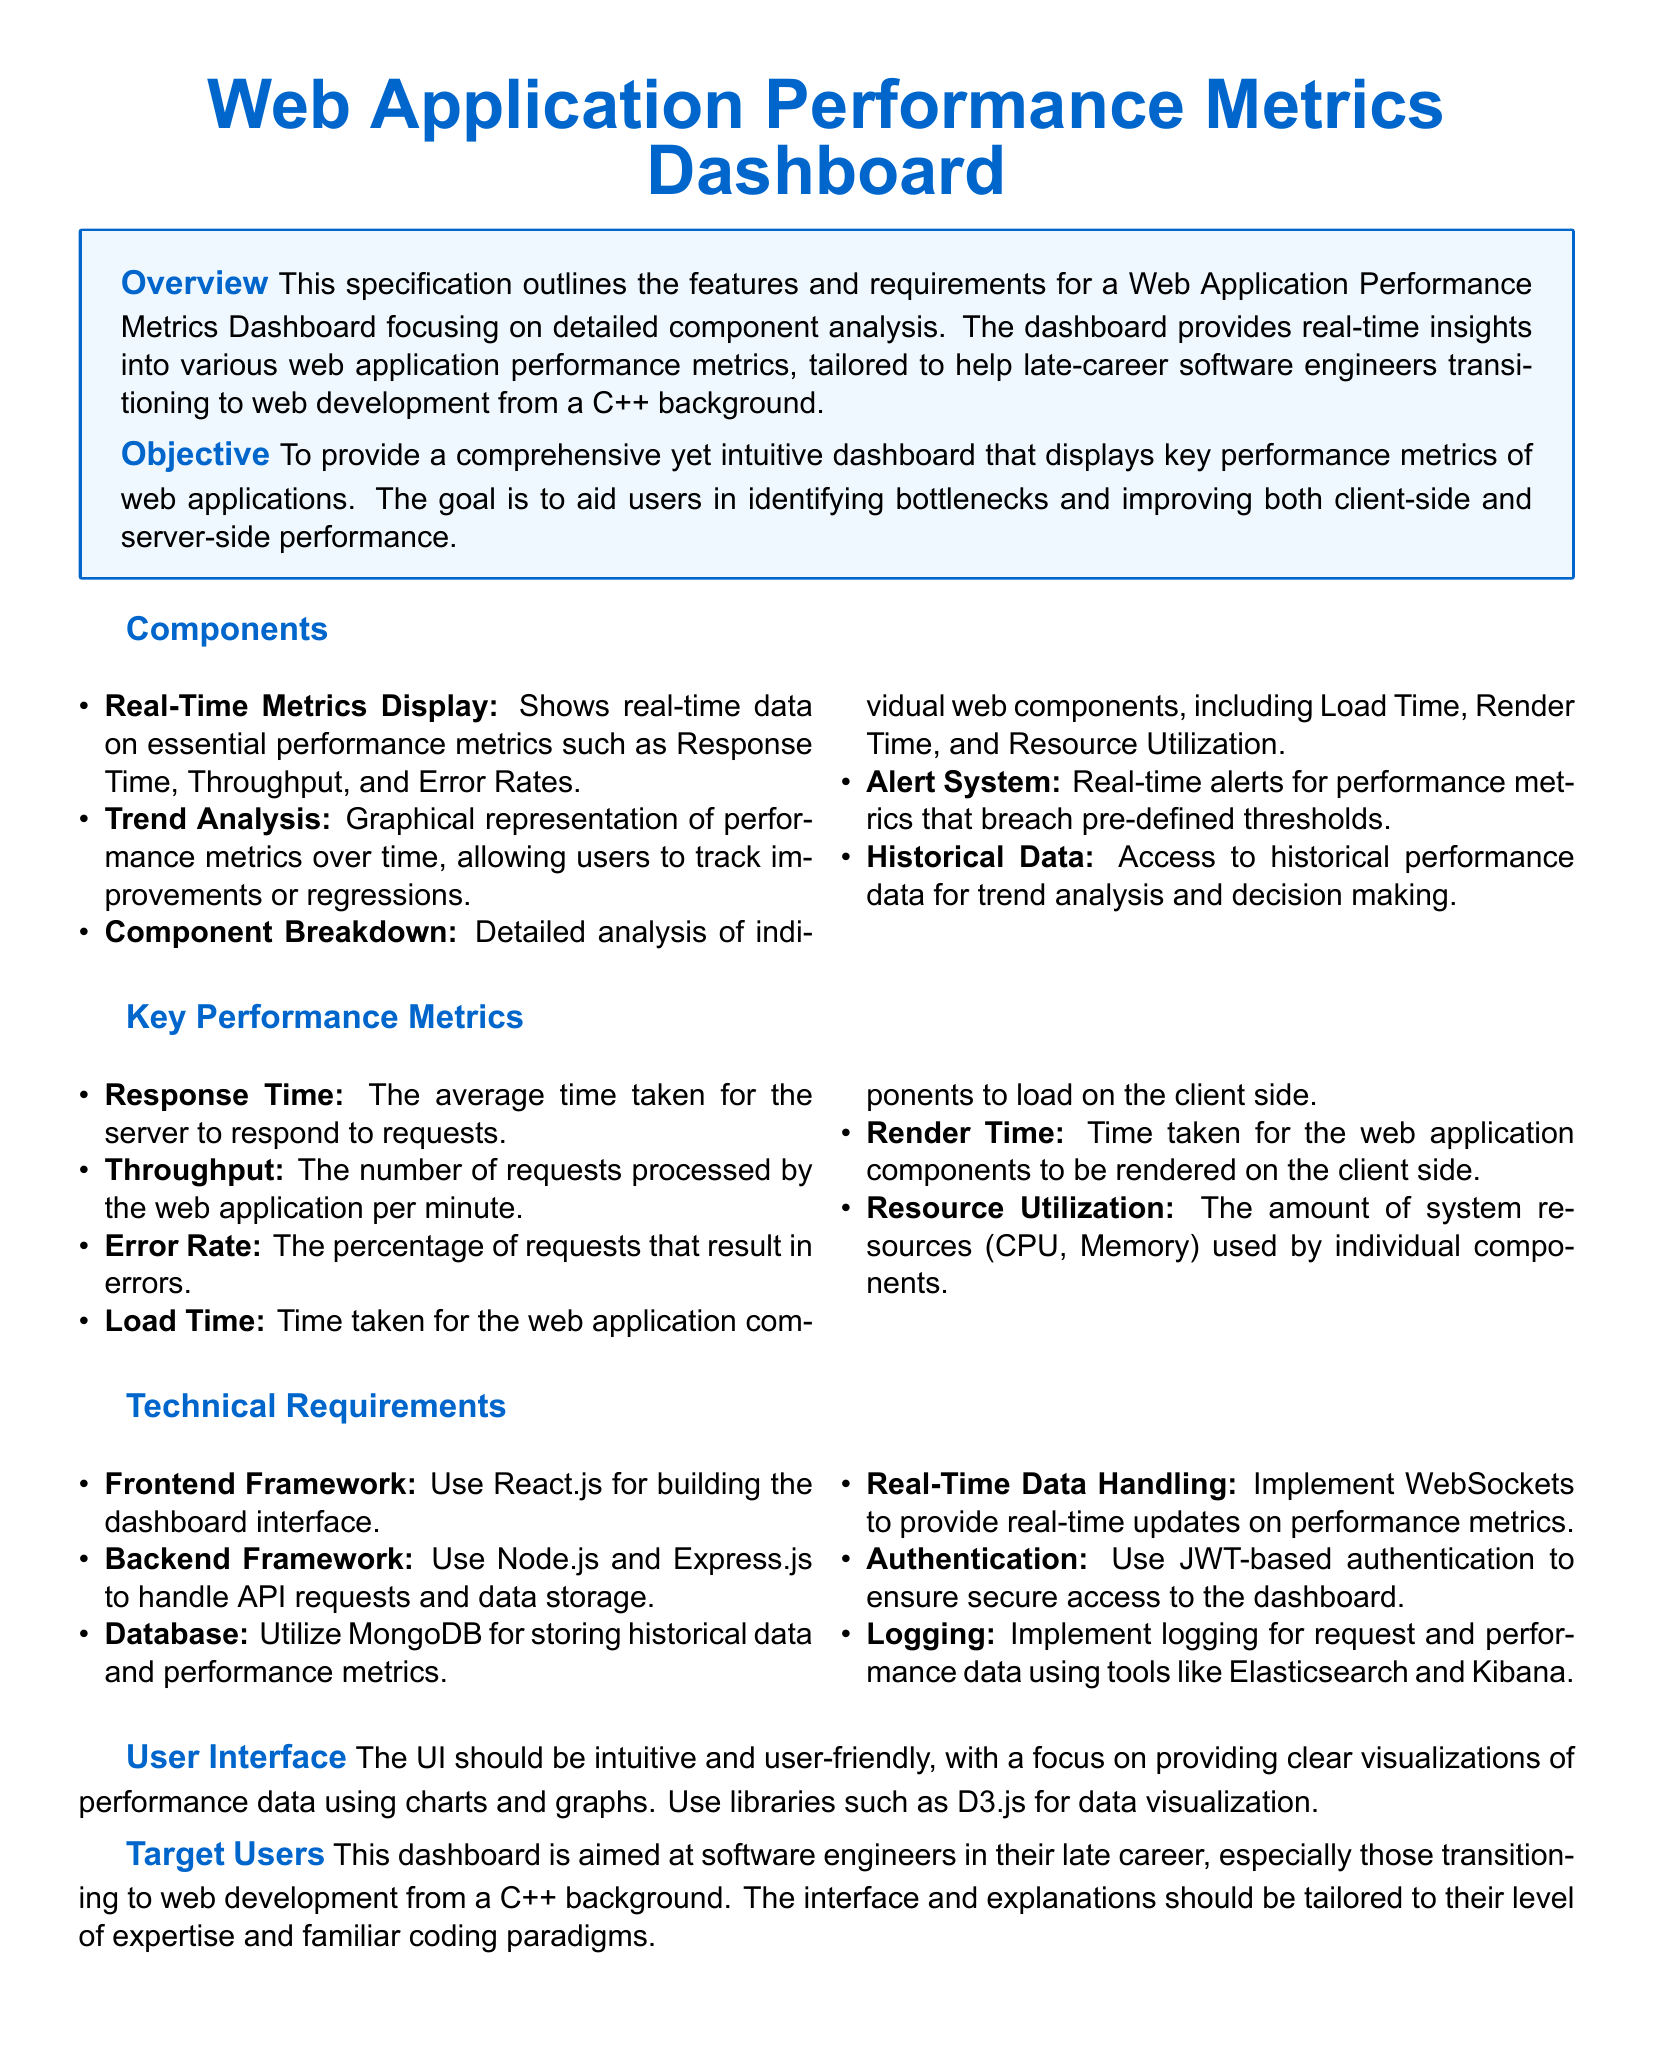What is the primary objective of the dashboard? The objective is to provide a comprehensive yet intuitive dashboard that displays key performance metrics of web applications.
Answer: Comprehensive dashboard Which technology is recommended for the frontend framework? The document specifies using React.js for building the dashboard interface.
Answer: React.js What performance metric measures the average time taken for server responses? This metric is referred to as Response Time in the document.
Answer: Response Time How many key performance metrics are listed? The document enumerates six key performance metrics.
Answer: Six What alerting feature is included in the dashboard? The dashboard includes a real-time alerts system for performance metrics.
Answer: Real-time alerts What database is suggested for storing historical data? MongoDB is the database recommended for storing historical data and performance metrics.
Answer: MongoDB Who is the target user of the dashboard? The target users are software engineers in their late career, especially those transitioning from C++.
Answer: Software engineers What technology is specified for handling real-time data? The document states that WebSockets should be implemented for real-time updates.
Answer: WebSockets 